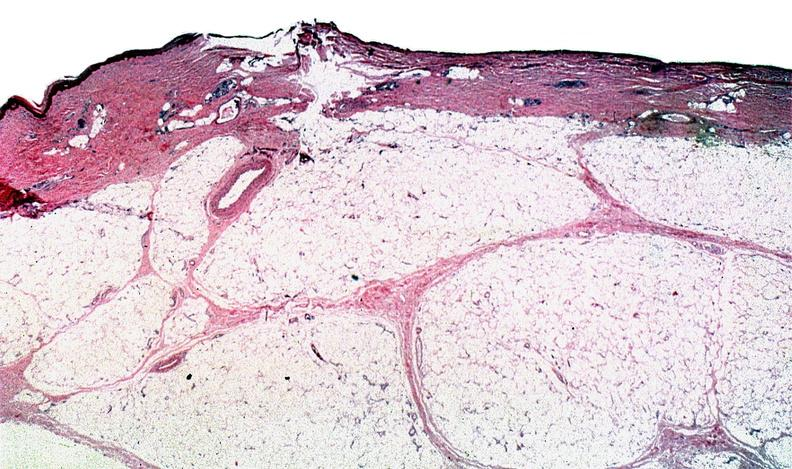does feet show thermal burned skin?
Answer the question using a single word or phrase. No 